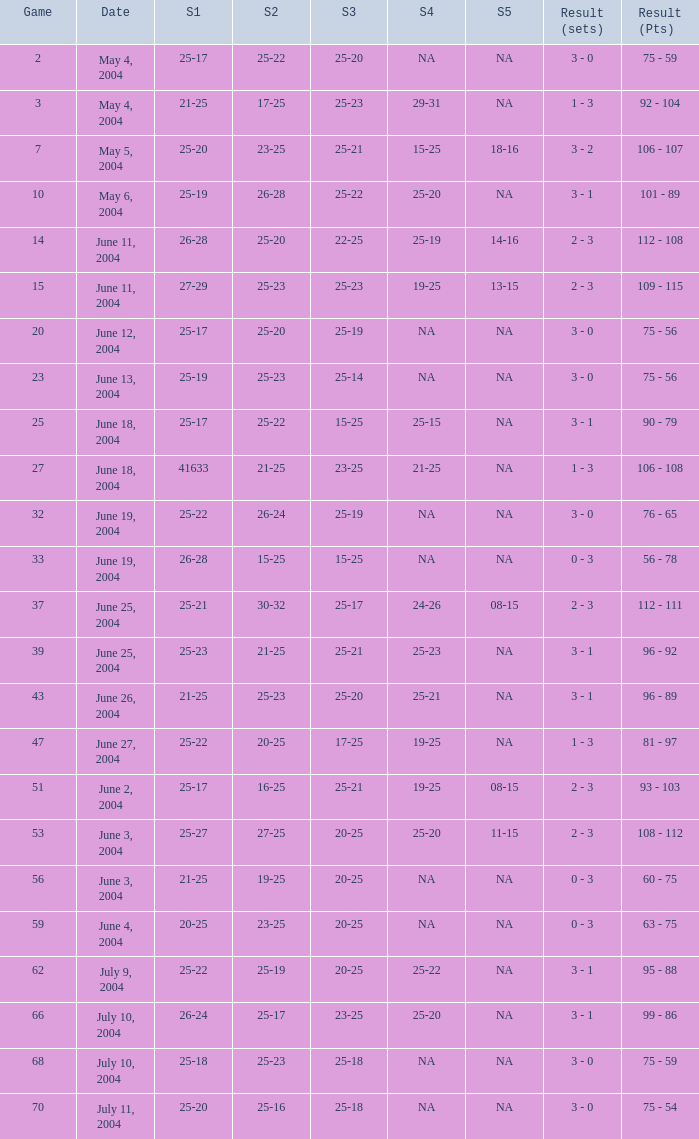What is the result of the game with a set 1 of 26-24? 99 - 86. 